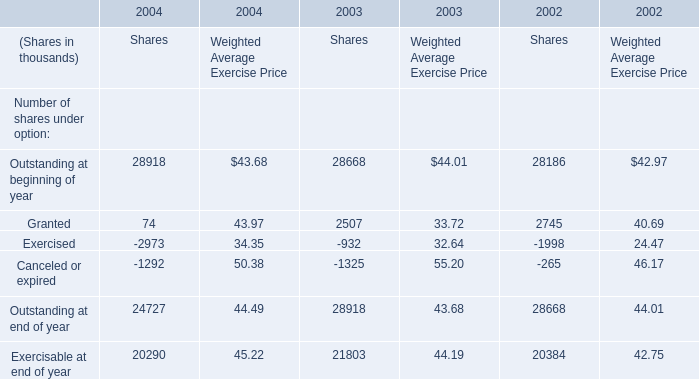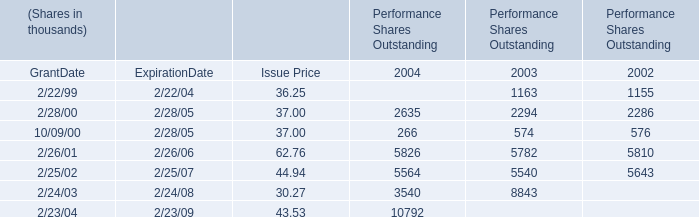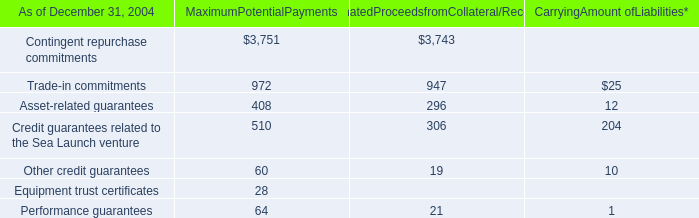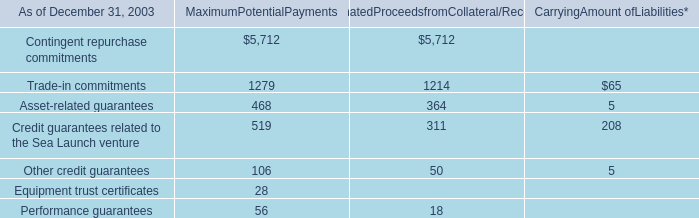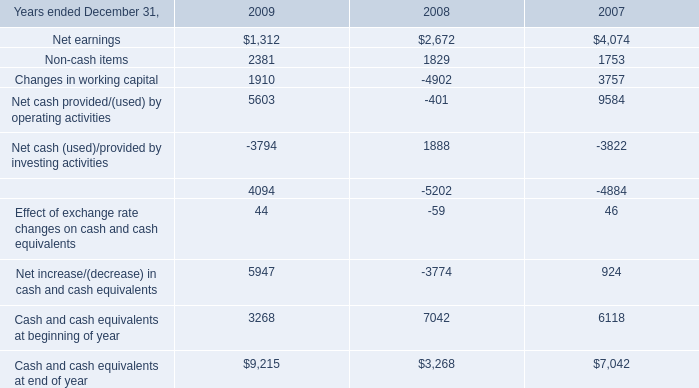What's the average of Granted and Exercised in shares in 2004? (in thousand) 
Computations: ((74 + 2973) / 2)
Answer: 1523.5. 